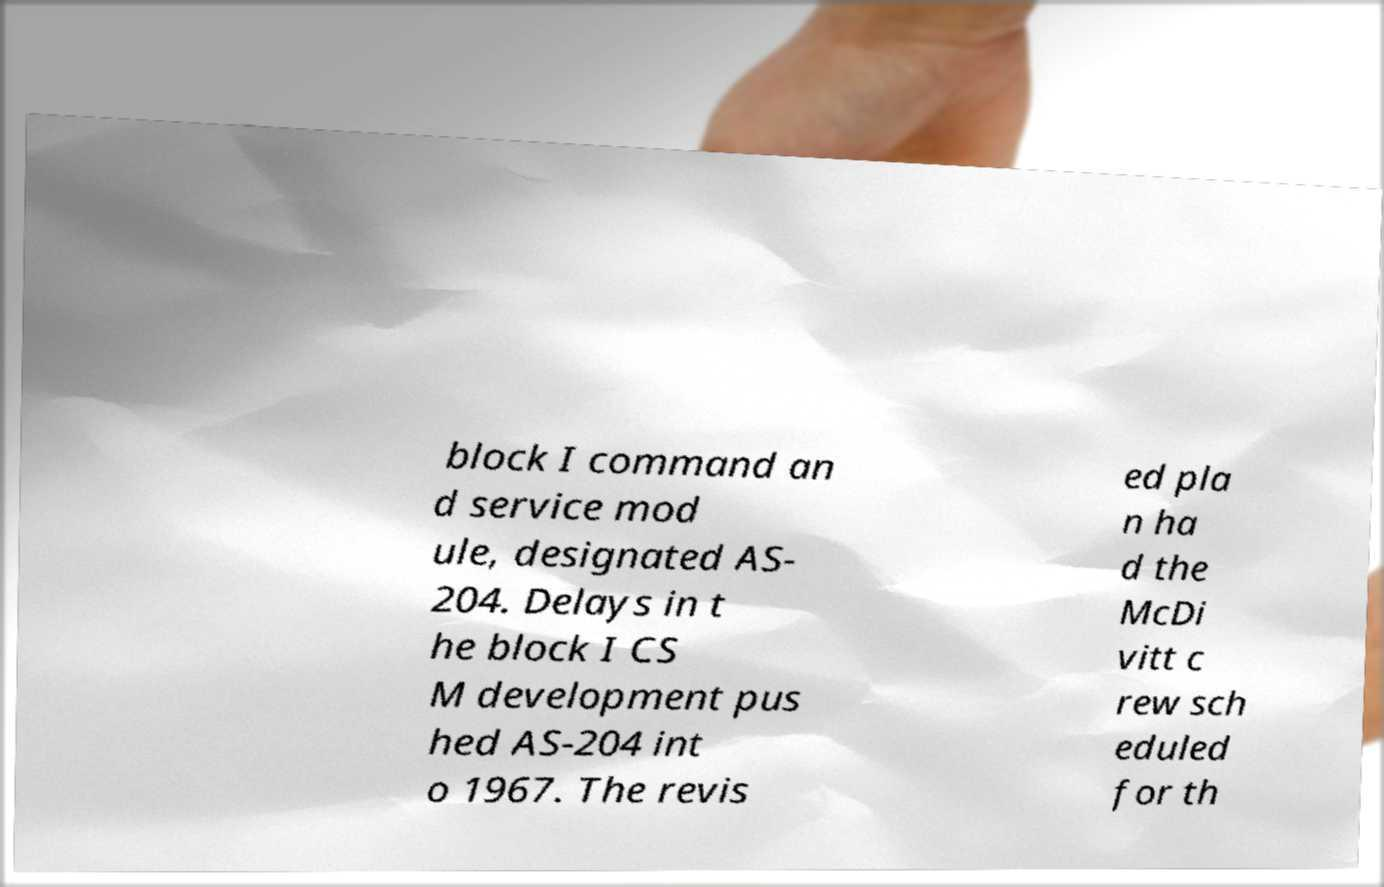There's text embedded in this image that I need extracted. Can you transcribe it verbatim? block I command an d service mod ule, designated AS- 204. Delays in t he block I CS M development pus hed AS-204 int o 1967. The revis ed pla n ha d the McDi vitt c rew sch eduled for th 